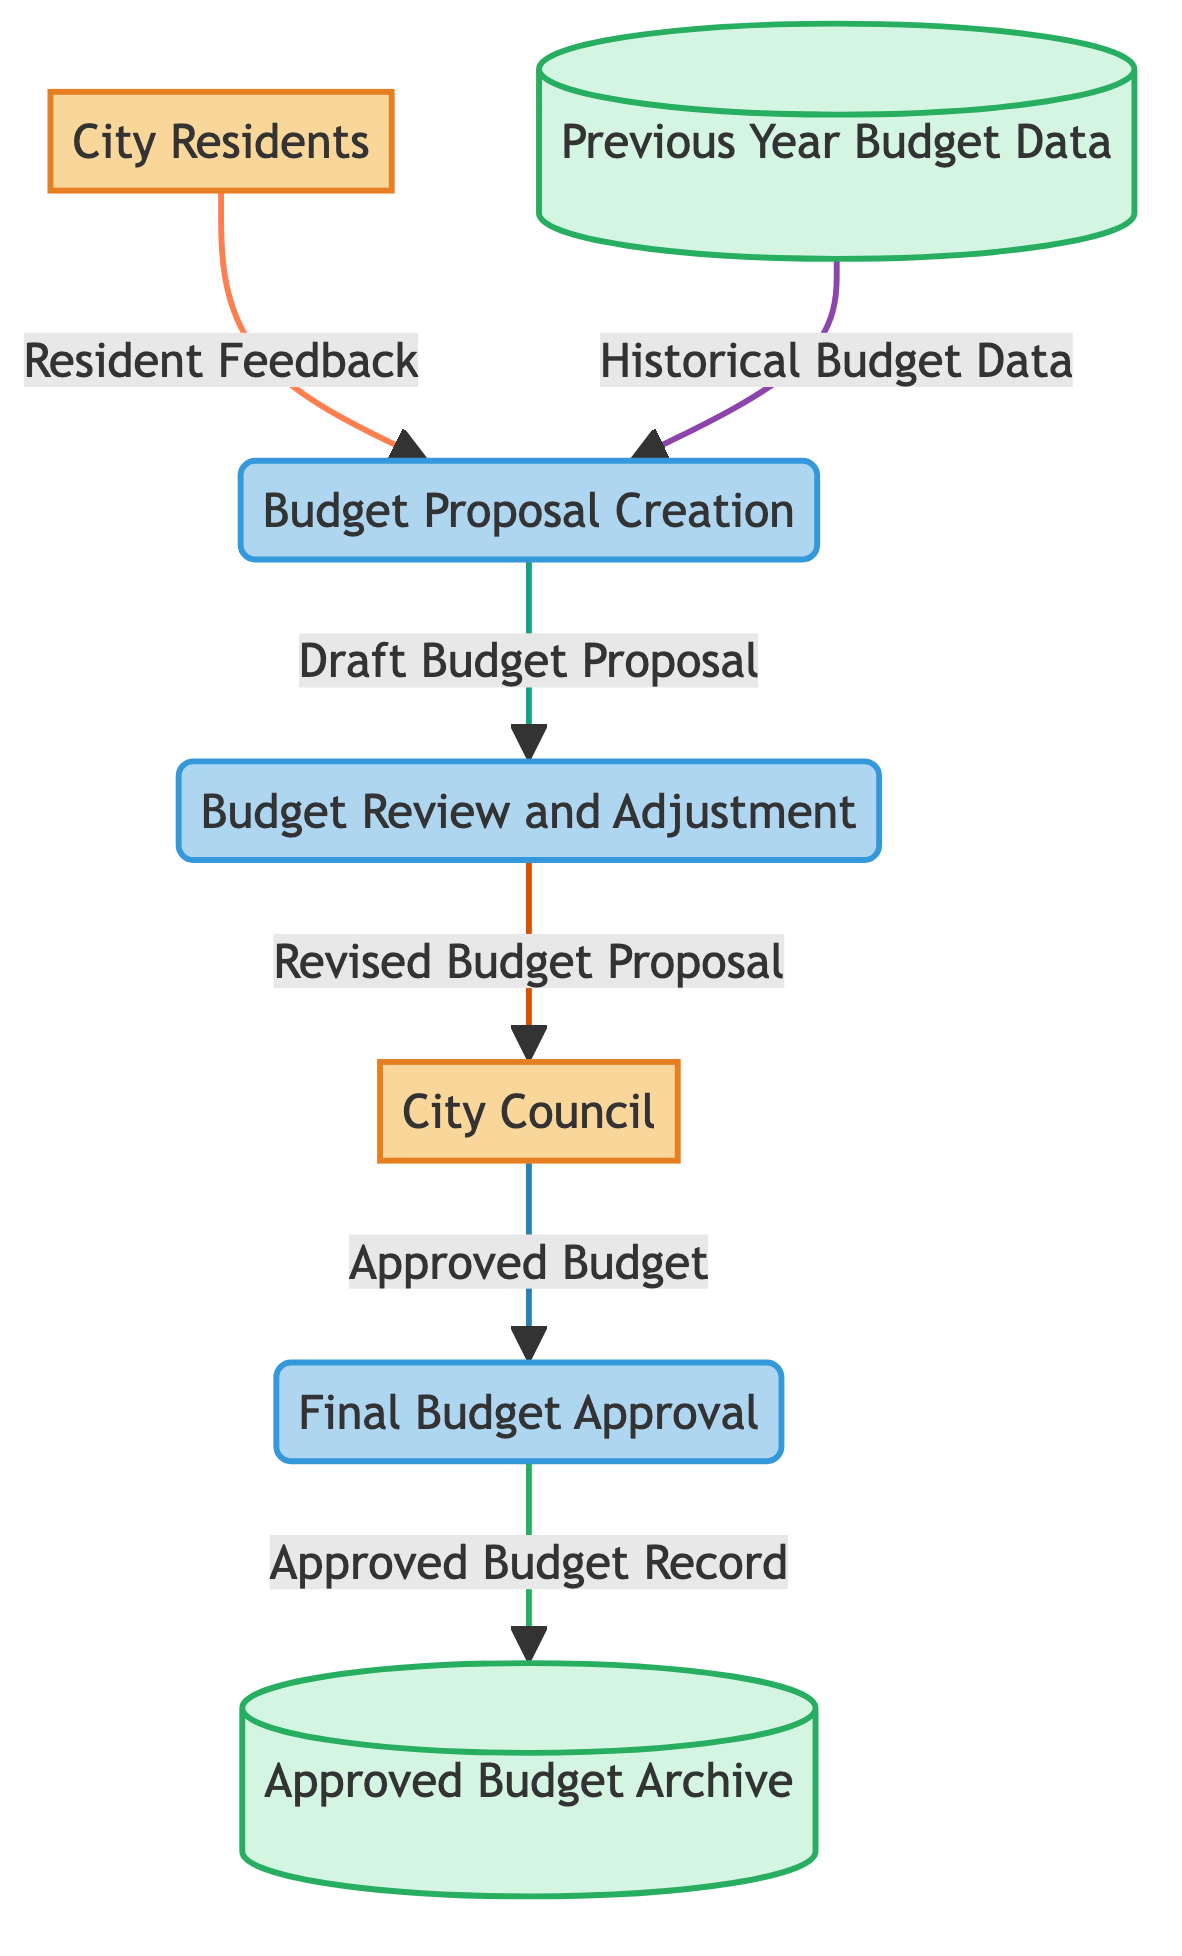What is the first input to the Budget Proposal Creation process? The first input to the Budget Proposal Creation process comes from City Residents, as they provide Resident Feedback.
Answer: Resident Feedback How many external entities are present in the diagram? There are two external entities in the diagram: City Residents and City Council.
Answer: 2 What is the output of the Final Budget Approval process? The output of the Final Budget Approval process is the Approved Budget.
Answer: Approved Budget Which data store holds historical budget information? The data store that holds historical budget information is the Previous Year Budget Data.
Answer: Previous Year Budget Data What connects the Budget Proposal Creation process to the Budget Review and Adjustment process? The connection is established through the Draft Budget Proposal, which is the output from Budget Proposal Creation to Budget Review and Adjustment.
Answer: Draft Budget Proposal What action does the City Council perform after receiving the Revised Budget Proposal? The City Council performs the action of approving the budget, leading to the creation of the Approved Budget.
Answer: Approving How does the Revised Budget Proposal reach the City Council? The Revised Budget Proposal is sent from the Budget Review and Adjustment process to the City Council.
Answer: Through Budget Review and Adjustment What happens to the Approved Budget after the Final Budget Approval? The Approved Budget is stored in the Approved Budget Archive for future reference after Final Budget Approval.
Answer: Stored in Approved Budget Archive How many processes are depicted in the diagram? There are three processes depicted in the diagram: Budget Proposal Creation, Budget Review and Adjustment, and Final Budget Approval.
Answer: 3 